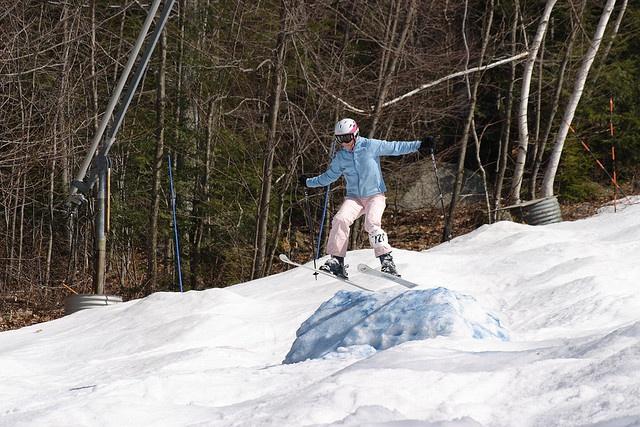Describe the objects in this image and their specific colors. I can see people in black, lightgray, gray, and darkgray tones and skis in black, darkgray, and lightgray tones in this image. 